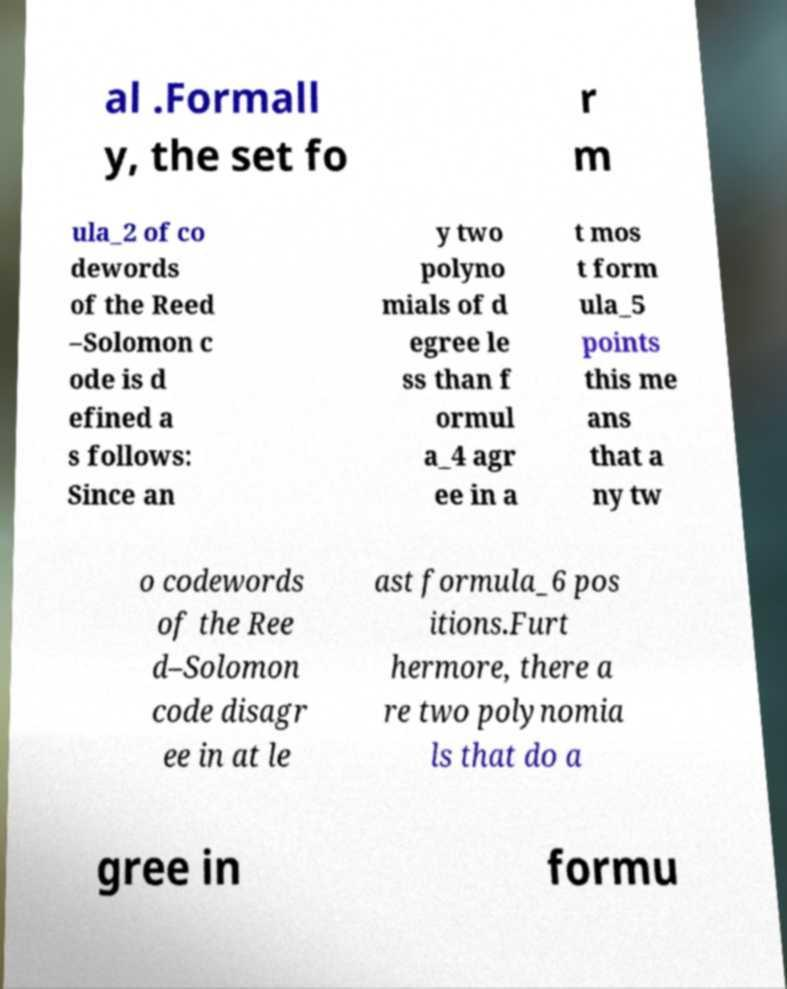Can you read and provide the text displayed in the image?This photo seems to have some interesting text. Can you extract and type it out for me? al .Formall y, the set fo r m ula_2 of co dewords of the Reed –Solomon c ode is d efined a s follows: Since an y two polyno mials of d egree le ss than f ormul a_4 agr ee in a t mos t form ula_5 points this me ans that a ny tw o codewords of the Ree d–Solomon code disagr ee in at le ast formula_6 pos itions.Furt hermore, there a re two polynomia ls that do a gree in formu 